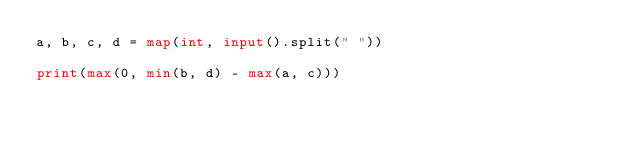Convert code to text. <code><loc_0><loc_0><loc_500><loc_500><_Python_>a, b, c, d = map(int, input().split(" "))

print(max(0, min(b, d) - max(a, c)))</code> 